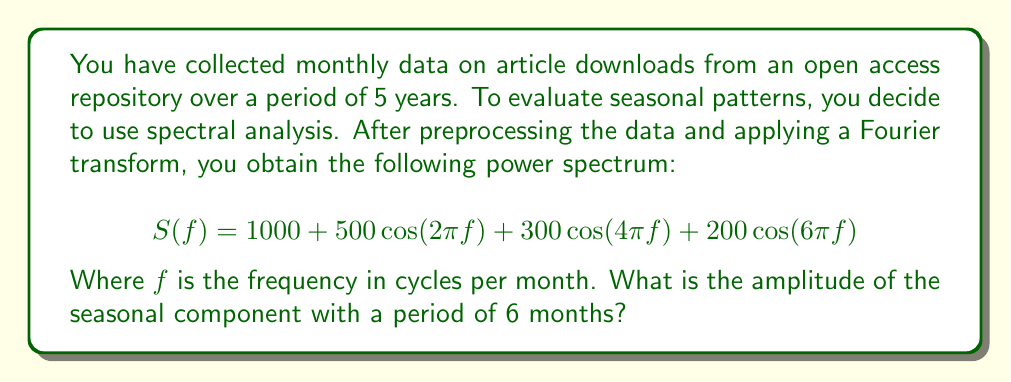Provide a solution to this math problem. To solve this problem, we need to follow these steps:

1. Understand the power spectrum equation:
   The given power spectrum is in the form of a Fourier series:
   $$S(f) = a_0 + \sum_{k=1}^{n} a_k\cos(2\pi kf)$$
   Where $a_0$ is the mean, and $a_k$ are the amplitudes of the cosine components.

2. Identify the frequency corresponding to a 6-month period:
   Frequency = 1 / Period
   $f = 1 / 6$ cycles per month

3. Determine which term in the equation corresponds to the 6-month period:
   The term $200\cos(6\pi f)$ corresponds to the 6-month period because:
   $6\pi f = 6\pi (1/6) = \pi$, which completes a full cycle every 6 months.

4. Extract the amplitude:
   The amplitude of the 6-month seasonal component is the coefficient of the corresponding cosine term, which is 200.

5. Interpret the result:
   In spectral analysis, the amplitude represents the strength of the periodic component. A higher amplitude indicates a stronger seasonal effect at that frequency.
Answer: The amplitude of the seasonal component with a period of 6 months is 200. 